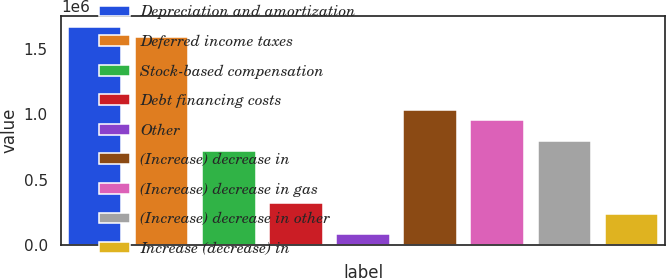Convert chart to OTSL. <chart><loc_0><loc_0><loc_500><loc_500><bar_chart><fcel>Depreciation and amortization<fcel>Deferred income taxes<fcel>Stock-based compensation<fcel>Debt financing costs<fcel>Other<fcel>(Increase) decrease in<fcel>(Increase) decrease in gas<fcel>(Increase) decrease in other<fcel>Increase (decrease) in<nl><fcel>1.66913e+06<fcel>1.58966e+06<fcel>715523<fcel>318186<fcel>79784.3<fcel>1.03339e+06<fcel>953925<fcel>794990<fcel>238719<nl></chart> 